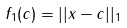Convert formula to latex. <formula><loc_0><loc_0><loc_500><loc_500>f _ { 1 } ( c ) = | | x - c | | _ { 1 }</formula> 